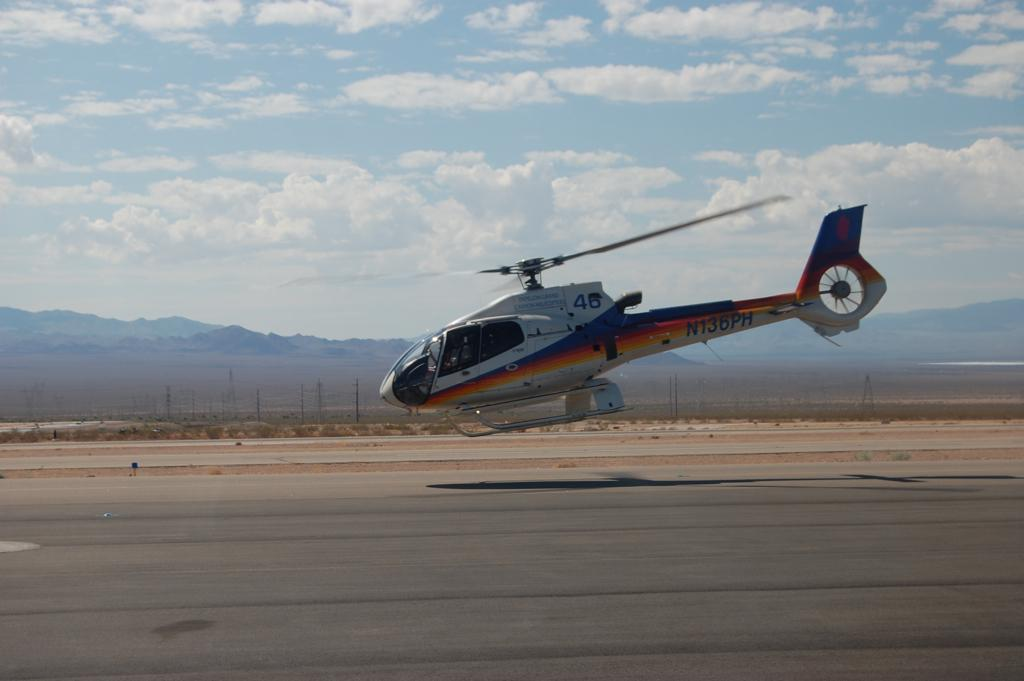What is the main subject of the image? The main subject of the image is a helicopter. What is the helicopter doing in the image? The helicopter is landing on the ground in the image. What can be seen in the background of the image? There are mountains visible in the background of the image. What type of chain can be seen connecting the helicopter to the mountains in the image? There is no chain connecting the helicopter to the mountains in the image. How does the helicopter rub against the snail in the image? There is no snail present in the image, and therefore no rubbing can be observed. 